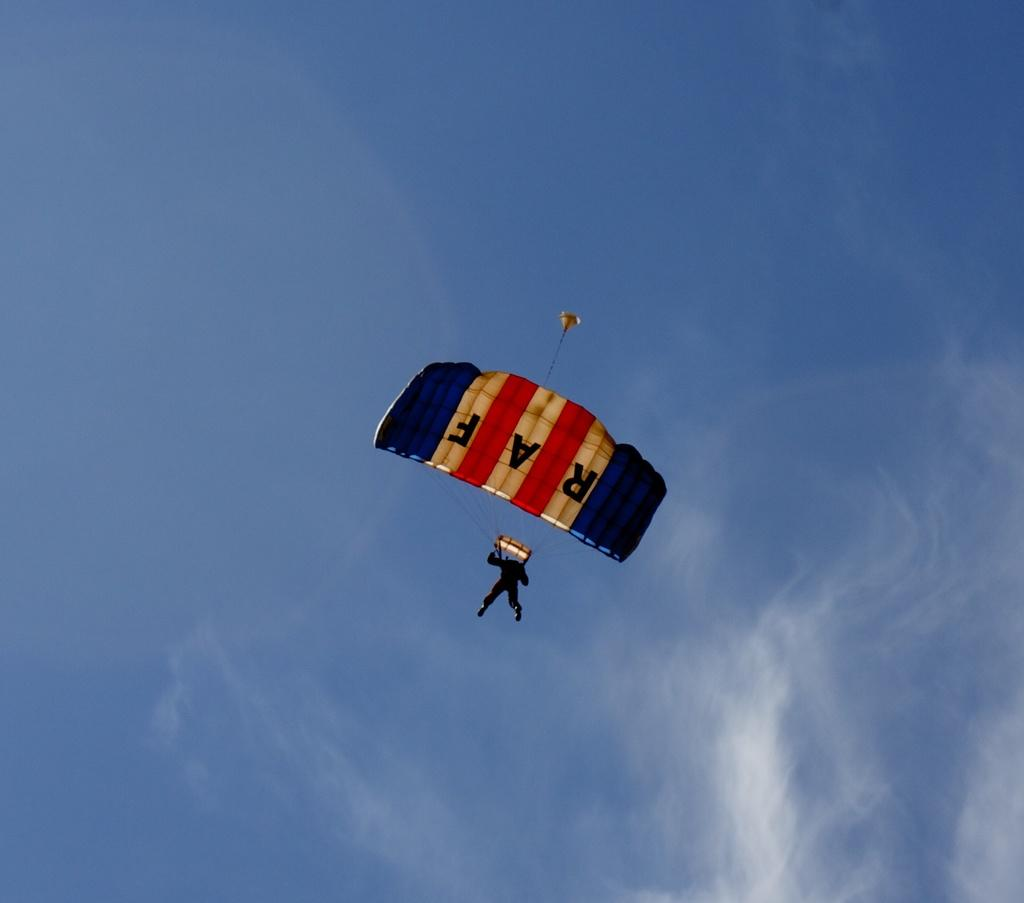<image>
Summarize the visual content of the image. A man from the RAF is parachuting to the ground. 